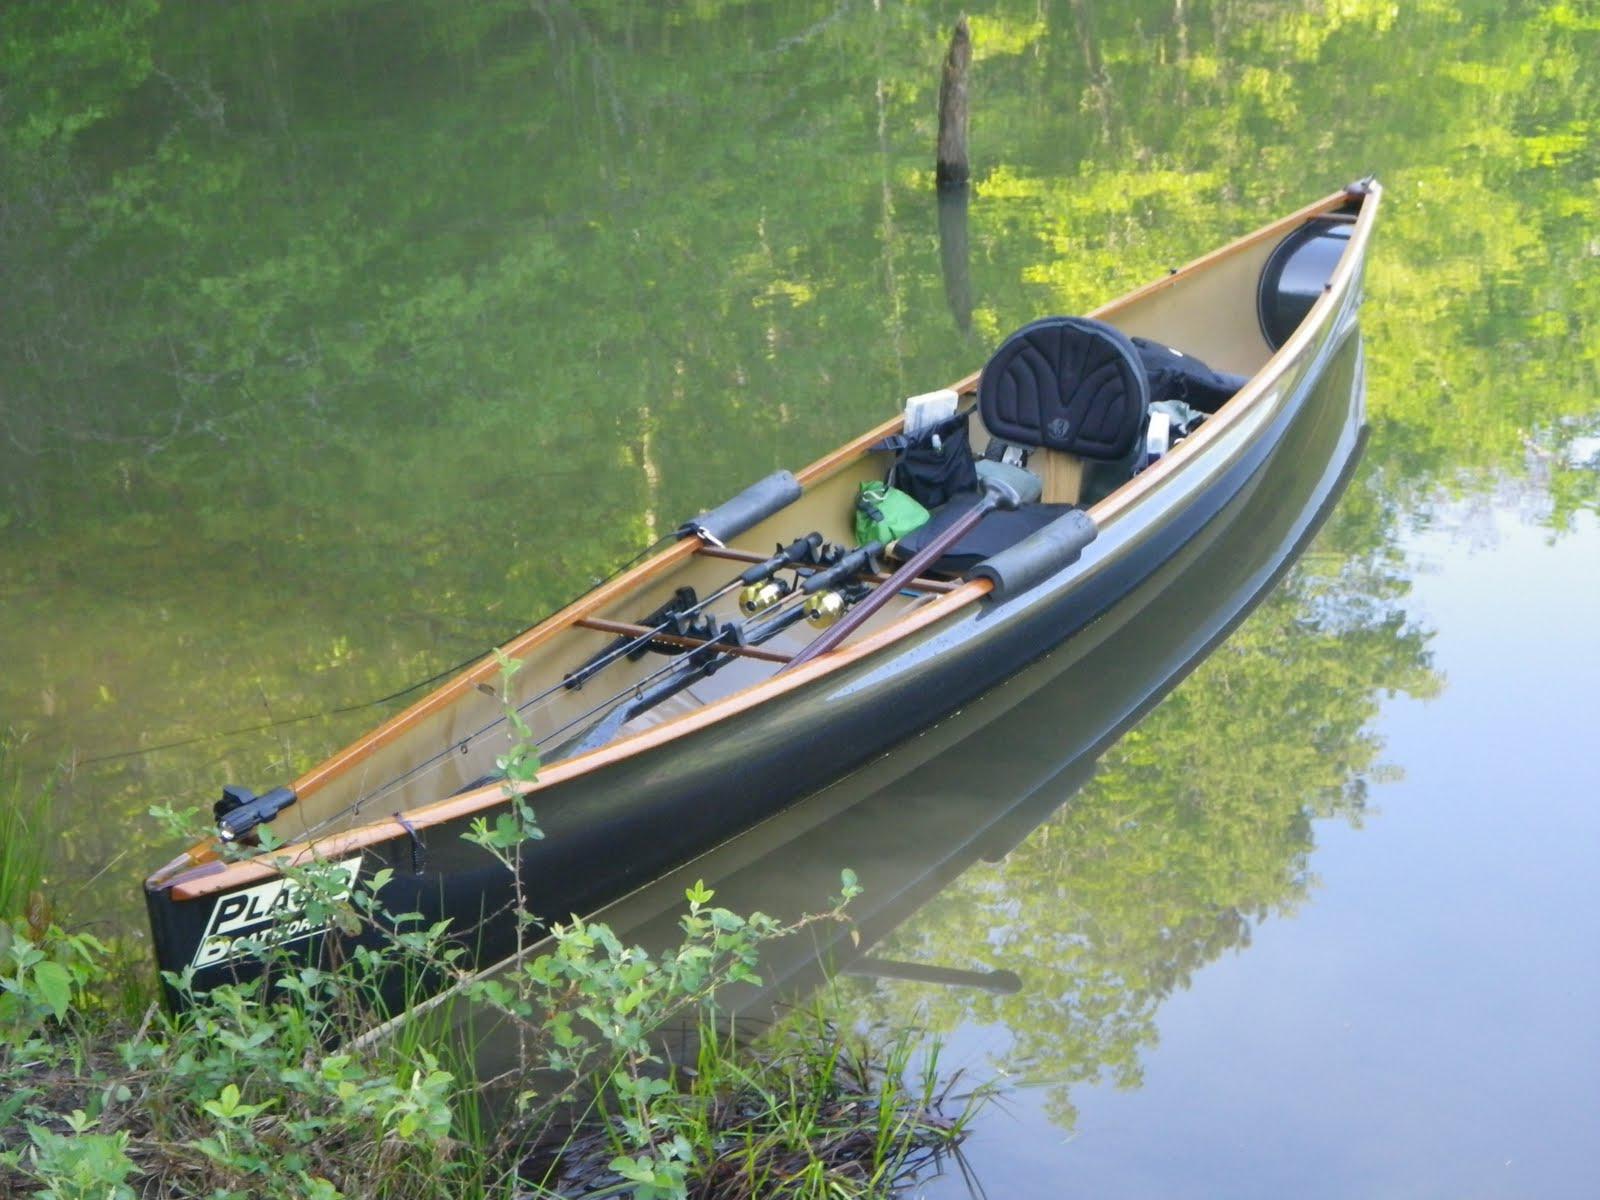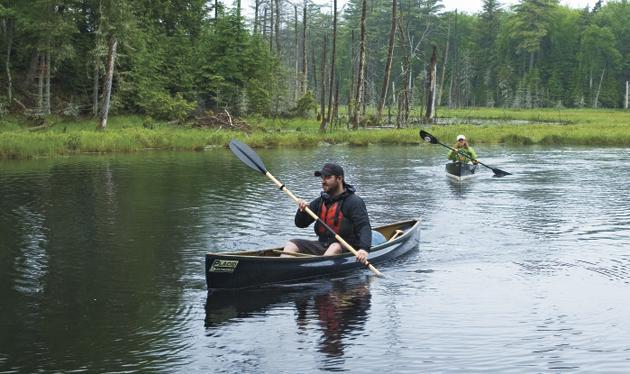The first image is the image on the left, the second image is the image on the right. Considering the images on both sides, is "One image shows multiple canoes with rowers in them heading leftward, and the other image features a single riderless canoe containing fishing poles floating on the water." valid? Answer yes or no. Yes. The first image is the image on the left, the second image is the image on the right. Analyze the images presented: Is the assertion "There is exactly one canoe without anyone in it." valid? Answer yes or no. Yes. 